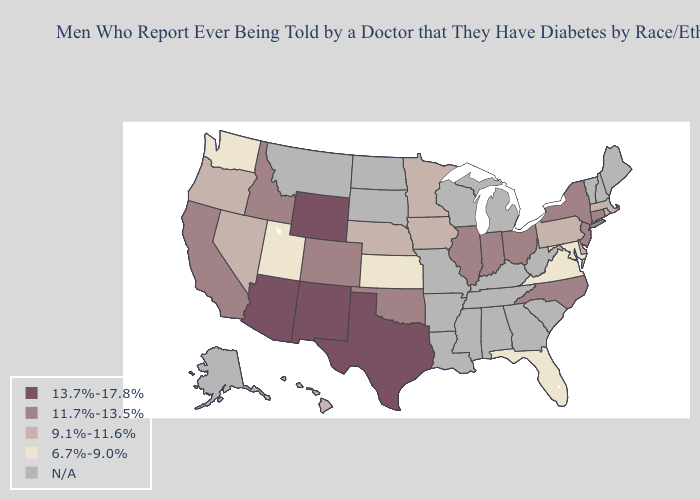What is the value of Missouri?
Keep it brief. N/A. What is the lowest value in states that border Arkansas?
Concise answer only. 11.7%-13.5%. What is the highest value in the South ?
Write a very short answer. 13.7%-17.8%. What is the value of Texas?
Concise answer only. 13.7%-17.8%. Which states have the lowest value in the USA?
Give a very brief answer. Florida, Kansas, Maryland, Utah, Virginia, Washington. Does Maryland have the lowest value in the USA?
Answer briefly. Yes. Does Nevada have the lowest value in the USA?
Write a very short answer. No. What is the highest value in the Northeast ?
Answer briefly. 11.7%-13.5%. Name the states that have a value in the range 6.7%-9.0%?
Short answer required. Florida, Kansas, Maryland, Utah, Virginia, Washington. Name the states that have a value in the range N/A?
Write a very short answer. Alabama, Alaska, Arkansas, Georgia, Kentucky, Louisiana, Maine, Michigan, Mississippi, Missouri, Montana, New Hampshire, North Dakota, South Carolina, South Dakota, Tennessee, Vermont, West Virginia, Wisconsin. What is the value of Pennsylvania?
Keep it brief. 9.1%-11.6%. 